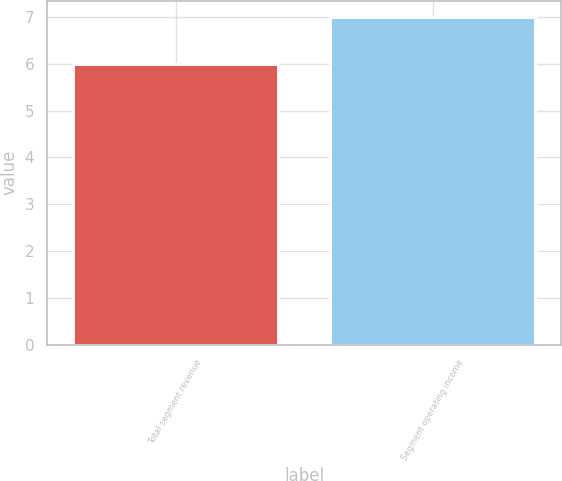Convert chart. <chart><loc_0><loc_0><loc_500><loc_500><bar_chart><fcel>Total segment revenue<fcel>Segment operating income<nl><fcel>6<fcel>7<nl></chart> 